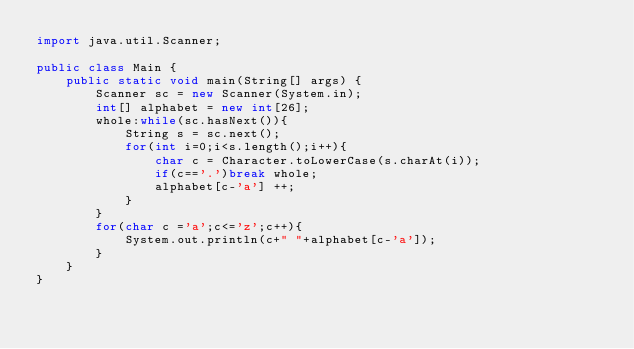Convert code to text. <code><loc_0><loc_0><loc_500><loc_500><_Java_>import java.util.Scanner;

public class Main {
    public static void main(String[] args) {
        Scanner sc = new Scanner(System.in);
        int[] alphabet = new int[26];
        whole:while(sc.hasNext()){
        	String s = sc.next();
        	for(int i=0;i<s.length();i++){
        		char c = Character.toLowerCase(s.charAt(i));
        		if(c=='.')break whole;
        		alphabet[c-'a'] ++;
        	}
        }
        for(char c ='a';c<='z';c++){
        	System.out.println(c+" "+alphabet[c-'a']);
        }
    }
}</code> 